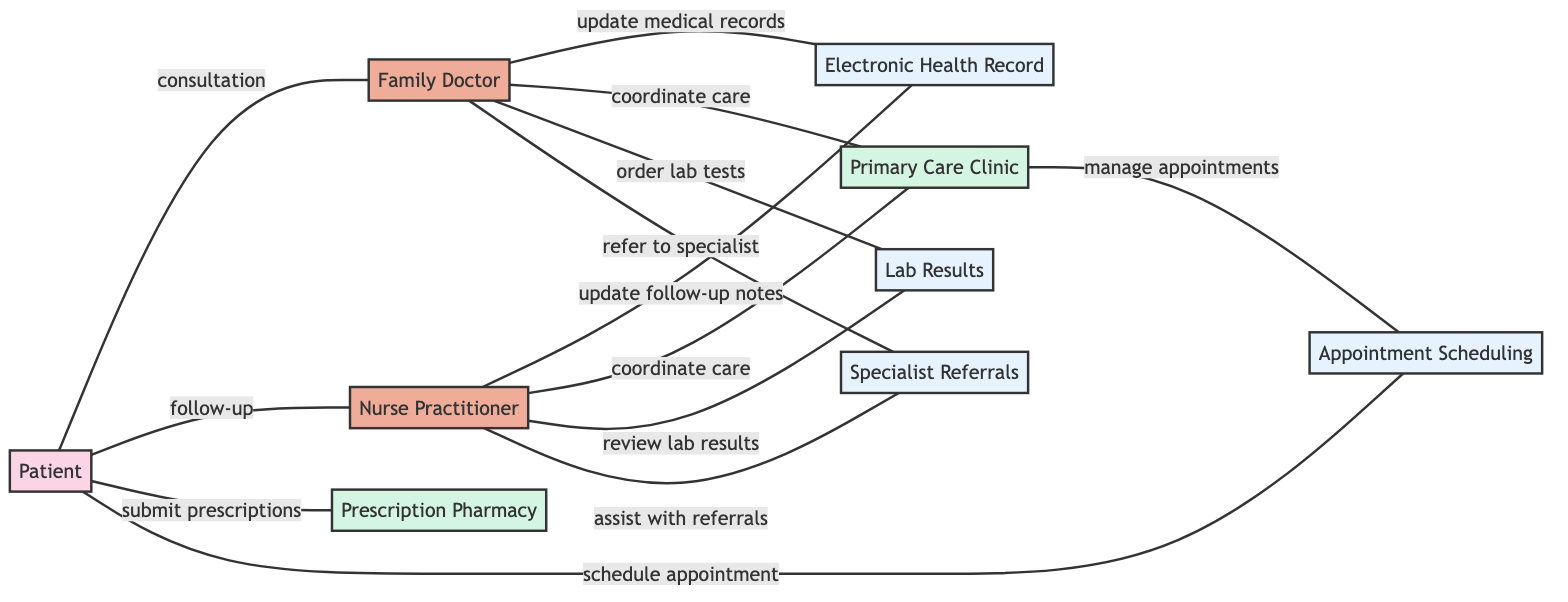What are the total number of nodes in the diagram? The diagram contains a list of nodes that include Patient, Family Doctor, Nurse Practitioner, Electronic Health Record, Primary Care Clinic, Prescription Pharmacy, Lab Results, Specialist Referrals, and Appointment Scheduling. Counting these gives a total of 9 nodes.
Answer: 9 How many edges connect the Patient to other nodes? The edges connected to the Patient node can be identified: consultation to Family Doctor, follow-up to Nurse Practitioner, submit prescriptions to Prescription Pharmacy, schedule appointment to Appointment Scheduling. This totals 4 edges.
Answer: 4 What is the relationship between the Family Doctor and Electronic Health Record? The edge between Family Doctor and Electronic Health Record is labeled ‘update medical records’, indicating the nature of their relationship.
Answer: update medical records Which node is connected to the Nurse Practitioner the most? By reviewing the edges connected to the Nurse Practitioner, we find edges to Electronic Health Record (update follow-up notes), Primary Care Clinic (coordinate care), Lab Results (review lab results), and Specialist Referrals (assist with referrals), which totals 4 edges. The Nurse Practitioner is thus connected to 4 nodes.
Answer: 4 Who submits prescriptions? In the graph, the edge to Prescription Pharmacy indicates that the Patient is responsible for submitting prescriptions.
Answer: Patient What types of nodes are involved in managing appointments? The nodes that manage appointments include Patient (schedules appointment) and Primary Care Clinic (manages appointments). Both nodes are directly connected by the edges that show this relationship.
Answer: Patient, Primary Care Clinic How many actions are related to Lab Results? The actions involving Lab Results include ordering lab tests from the Family Doctor and reviewing lab results by the Nurse Practitioner. Counting these gives a total of 2 actions.
Answer: 2 Which professional assists with referrals? The edge leading from Nurse Practitioner to Specialist Referrals states 'assist with referrals', indicating that the Nurse Practitioner is the professional assisting in this process.
Answer: Nurse Practitioner How many systems are represented in the diagram? The systems in the diagram are Electronic Health Record, Lab Results, Specialist Referrals, and Appointment Scheduling. By counting these, we discover there are 4 systems represented.
Answer: 4 